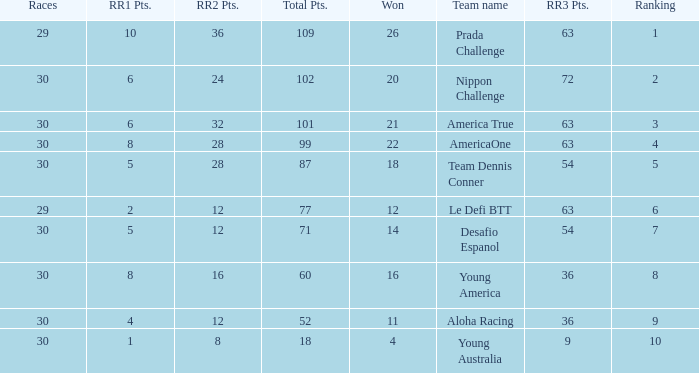Name the ranking for rr2 pts being 8 10.0. 